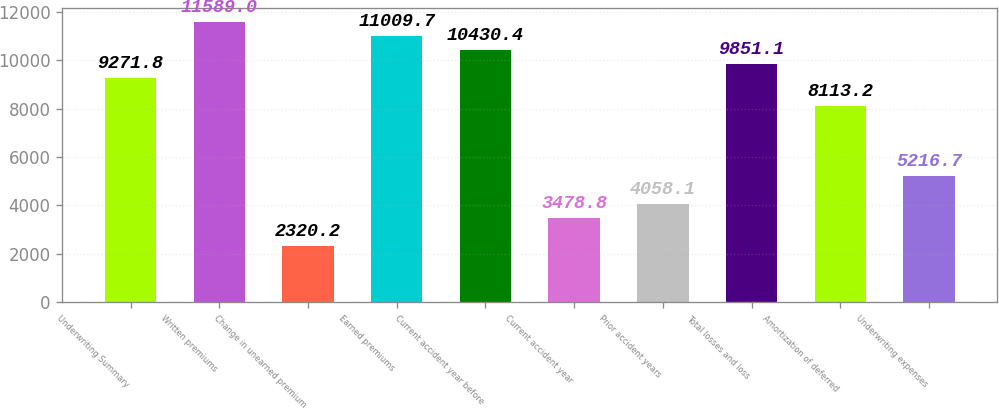<chart> <loc_0><loc_0><loc_500><loc_500><bar_chart><fcel>Underwriting Summary<fcel>Written premiums<fcel>Change in unearned premium<fcel>Earned premiums<fcel>Current accident year before<fcel>Current accident year<fcel>Prior accident years<fcel>Total losses and loss<fcel>Amortization of deferred<fcel>Underwriting expenses<nl><fcel>9271.8<fcel>11589<fcel>2320.2<fcel>11009.7<fcel>10430.4<fcel>3478.8<fcel>4058.1<fcel>9851.1<fcel>8113.2<fcel>5216.7<nl></chart> 